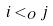<formula> <loc_0><loc_0><loc_500><loc_500>i < _ { O } j</formula> 